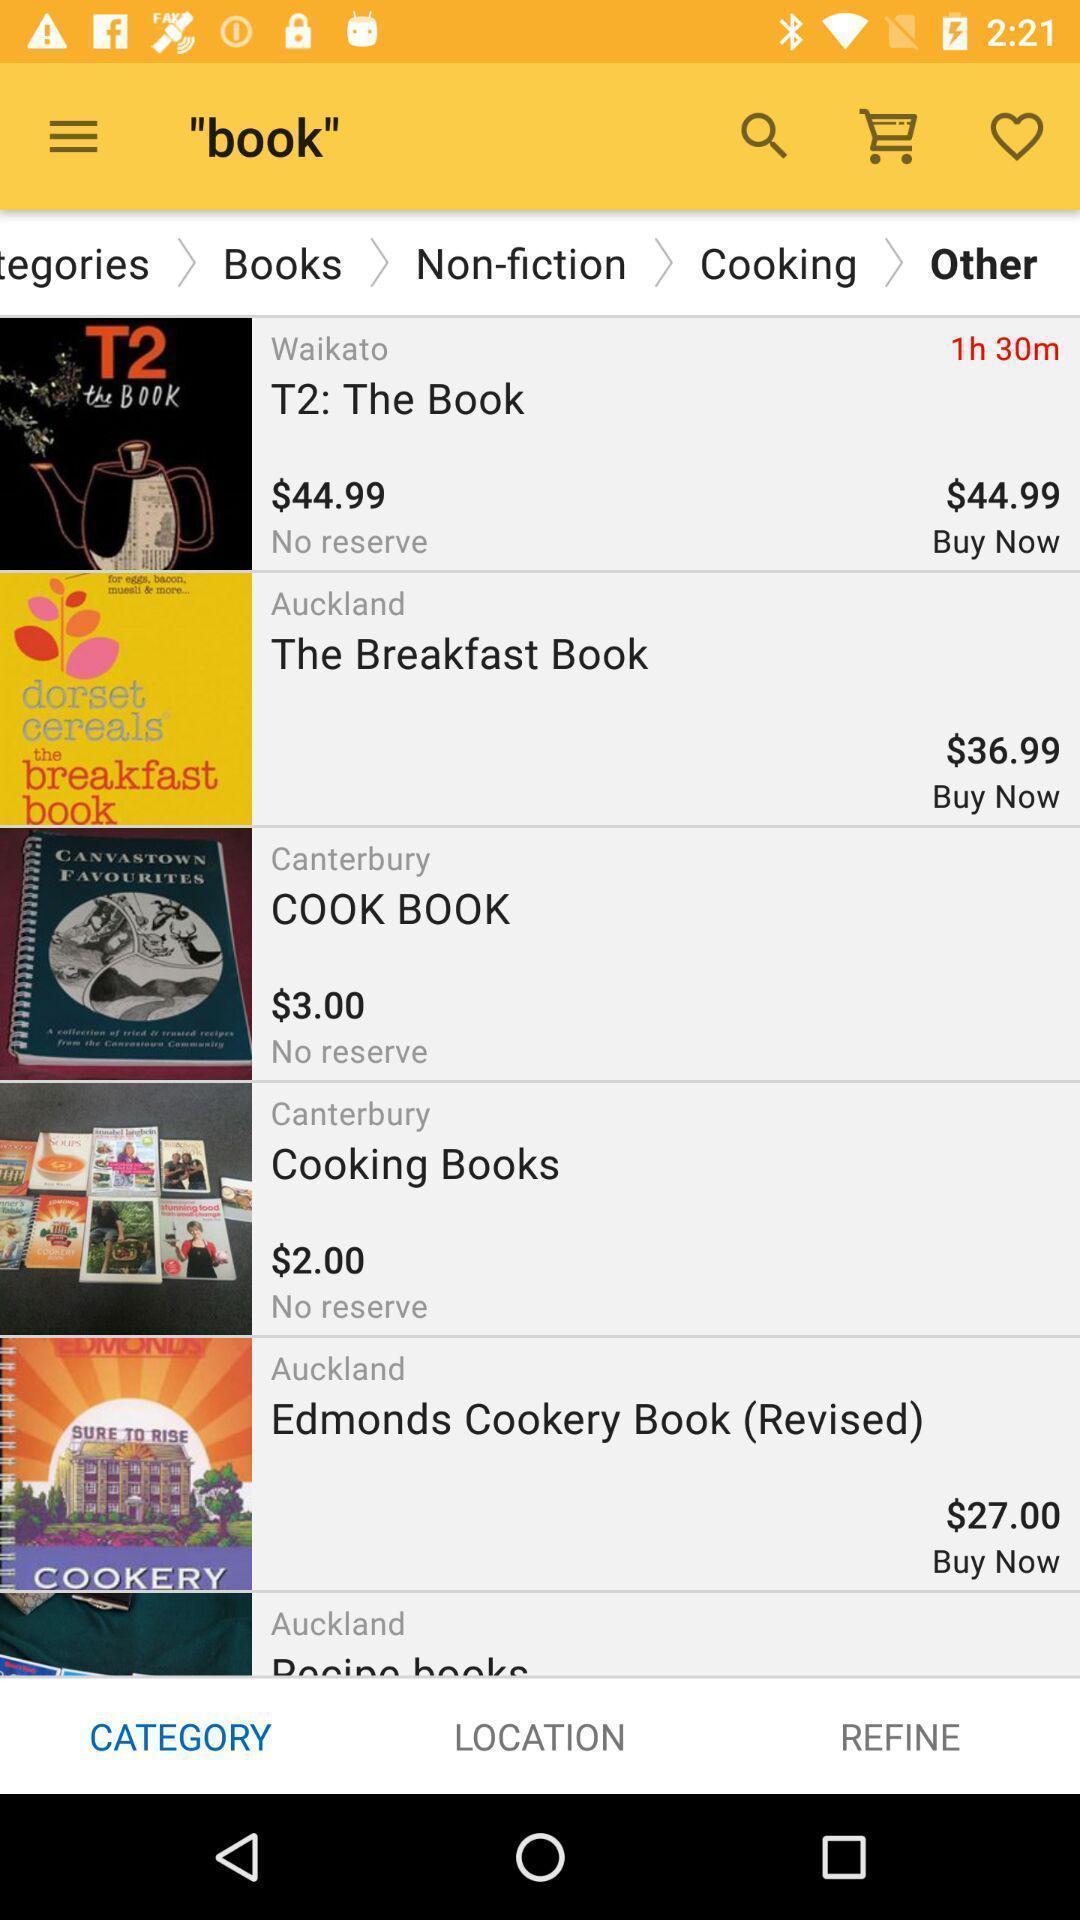Tell me what you see in this picture. Page displays list of different books in app. 